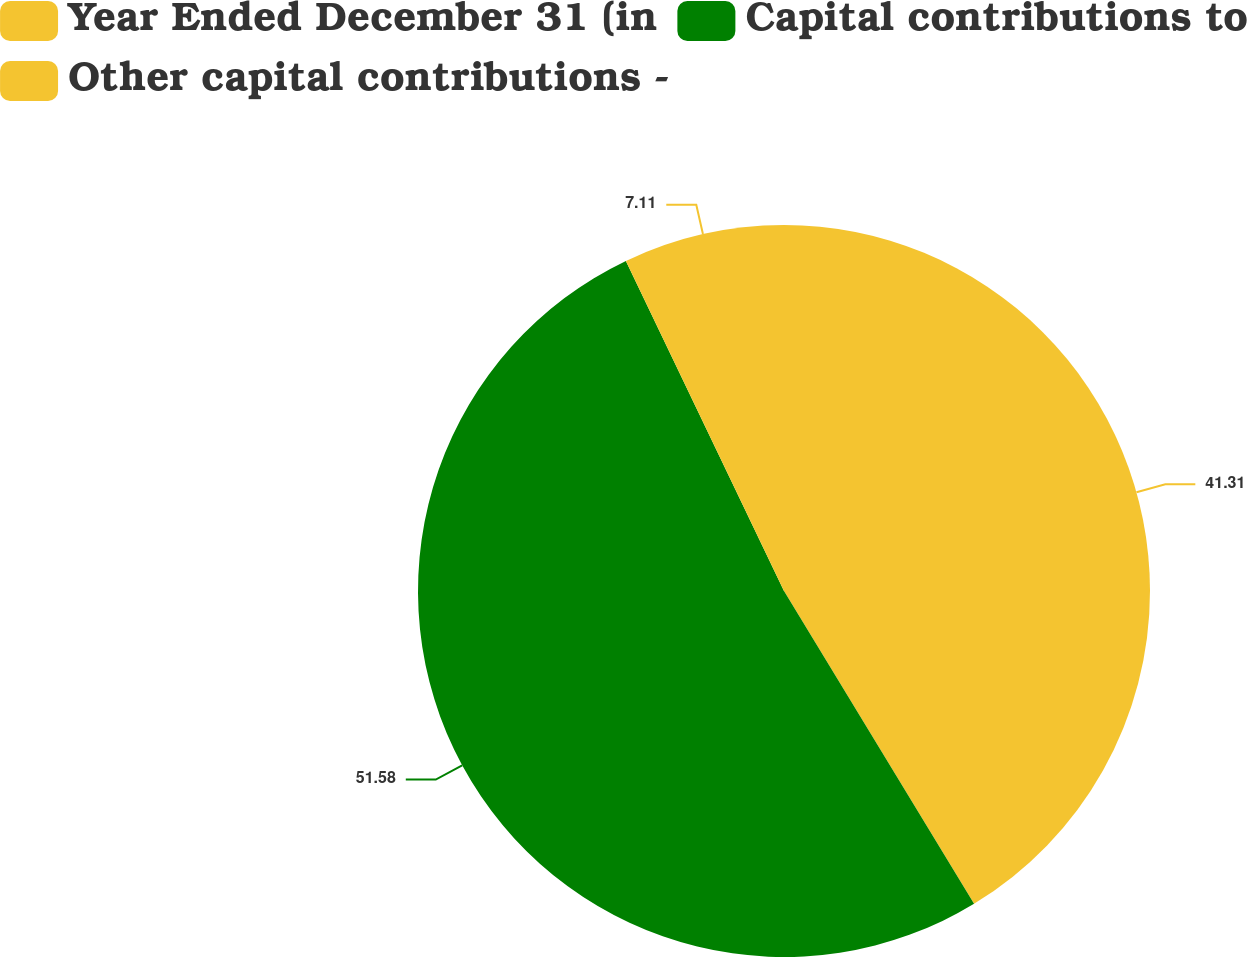Convert chart. <chart><loc_0><loc_0><loc_500><loc_500><pie_chart><fcel>Year Ended December 31 (in<fcel>Capital contributions to<fcel>Other capital contributions -<nl><fcel>41.31%<fcel>51.58%<fcel>7.11%<nl></chart> 